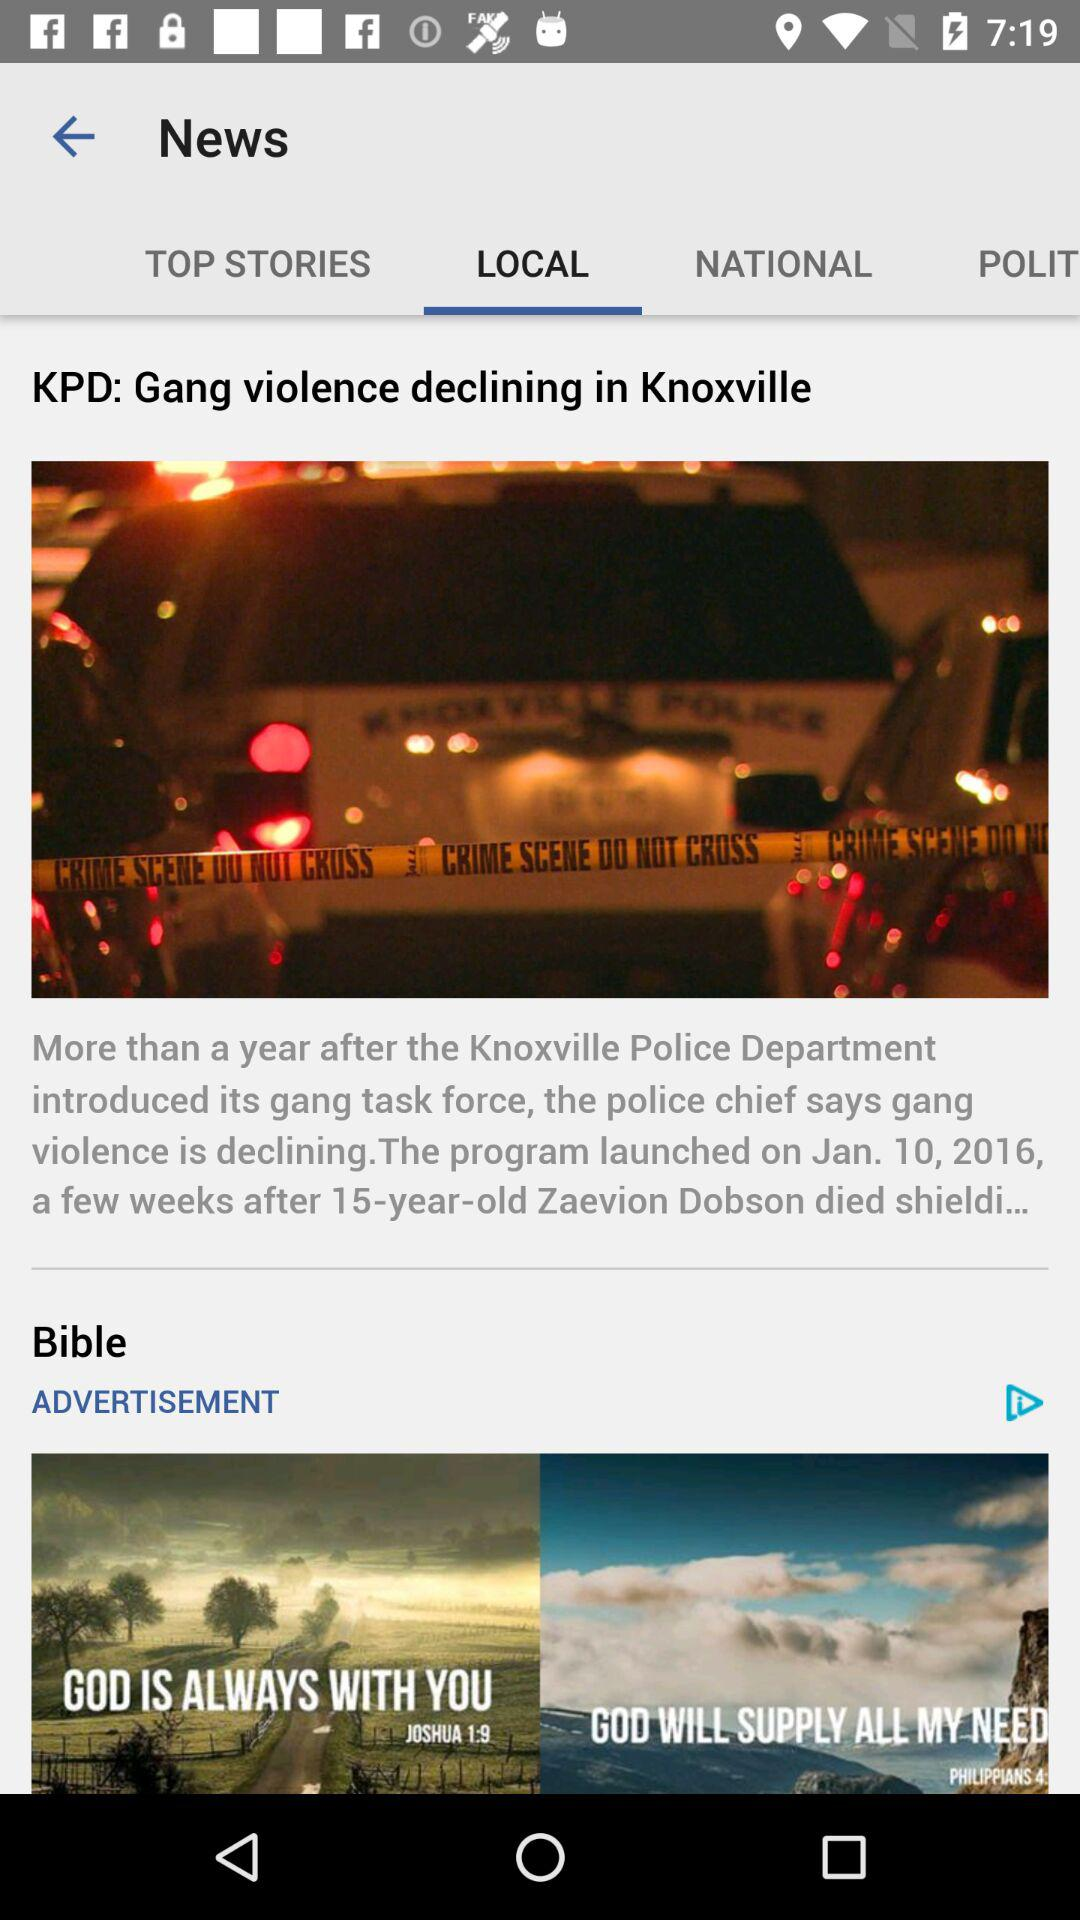What is the title of the article? The title of the article is "KPD: Gang violence declining in Knoxville". 